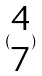Convert formula to latex. <formula><loc_0><loc_0><loc_500><loc_500>( \begin{matrix} 4 \\ 7 \end{matrix} )</formula> 